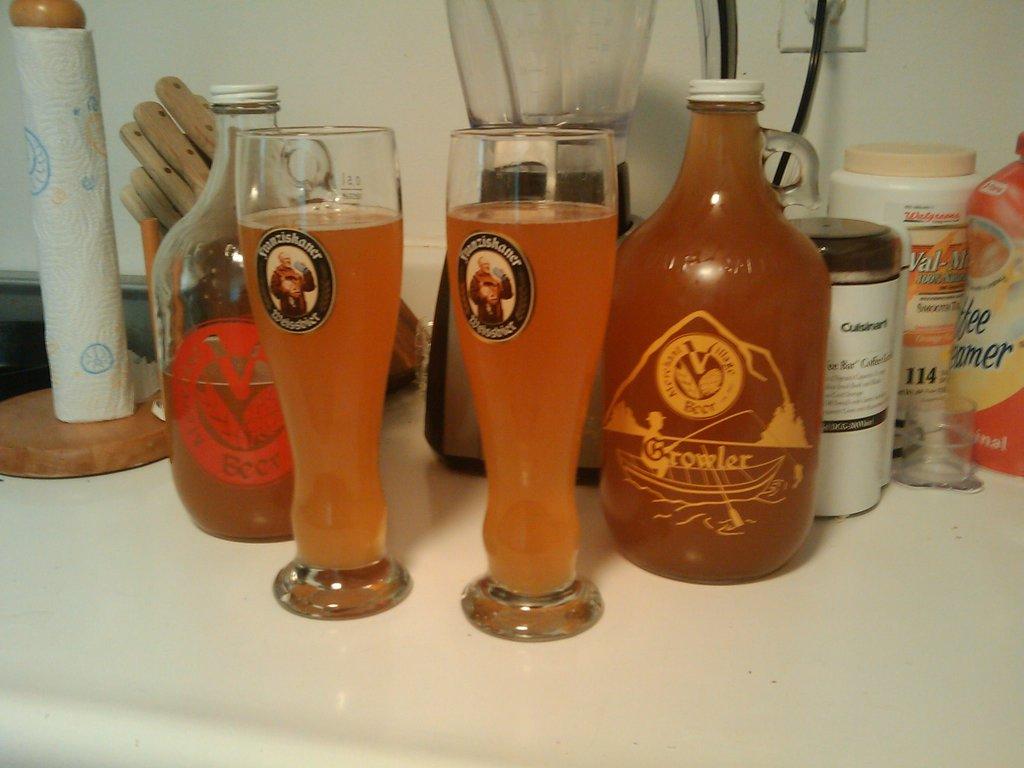Which national drug store chain is referenced on the white canister with the tan lid on the right?
Give a very brief answer. Walgreens. 